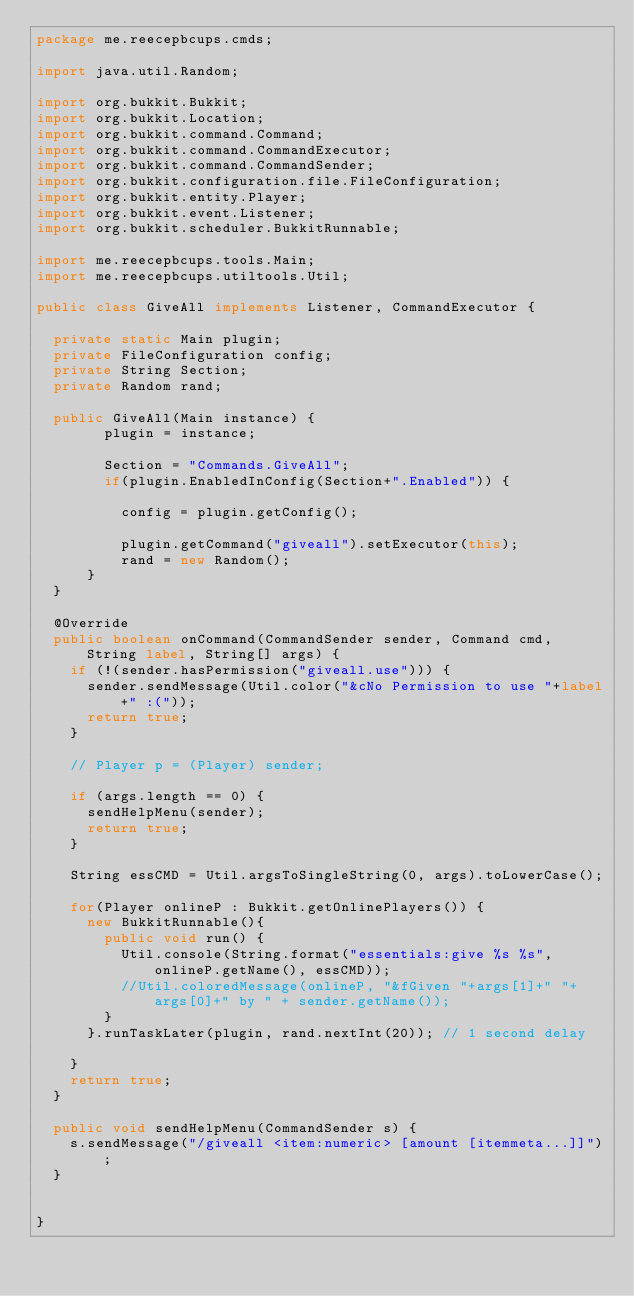Convert code to text. <code><loc_0><loc_0><loc_500><loc_500><_Java_>package me.reecepbcups.cmds;

import java.util.Random;

import org.bukkit.Bukkit;
import org.bukkit.Location;
import org.bukkit.command.Command;
import org.bukkit.command.CommandExecutor;
import org.bukkit.command.CommandSender;
import org.bukkit.configuration.file.FileConfiguration;
import org.bukkit.entity.Player;
import org.bukkit.event.Listener;
import org.bukkit.scheduler.BukkitRunnable;

import me.reecepbcups.tools.Main;
import me.reecepbcups.utiltools.Util;

public class GiveAll implements Listener, CommandExecutor {

	private static Main plugin;
	private FileConfiguration config;
	private String Section;
	private Random rand;
	
	public GiveAll(Main instance) {
        plugin = instance;
        
        Section = "Commands.GiveAll";                
        if(plugin.EnabledInConfig(Section+".Enabled")) {
        	
        	config = plugin.getConfig();	

        	plugin.getCommand("giveall").setExecutor(this);	
        	rand = new Random();
    	}
	}
	
	@Override
	public boolean onCommand(CommandSender sender, Command cmd, String label, String[] args) {		
		if (!(sender.hasPermission("giveall.use"))) {		
			sender.sendMessage(Util.color("&cNo Permission to use "+label+" :("));
			return true;			
		}
		
		// Player p = (Player) sender;

		if (args.length == 0) {
			sendHelpMenu(sender);
			return true;
		}	
		
		String essCMD = Util.argsToSingleString(0, args).toLowerCase();
		
		for(Player onlineP : Bukkit.getOnlinePlayers()) {
			new BukkitRunnable(){
				public void run() {	
					Util.console(String.format("essentials:give %s %s", onlineP.getName(), essCMD));
					//Util.coloredMessage(onlineP, "&fGiven "+args[1]+" "+args[0]+" by " + sender.getName());
				}
			}.runTaskLater(plugin, rand.nextInt(20)); // 1 second delay			
		}		
		return true;				
	}
	
	public void sendHelpMenu(CommandSender s) {
		s.sendMessage("/giveall <item:numeric> [amount [itemmeta...]]");
	}
	
	
}
</code> 